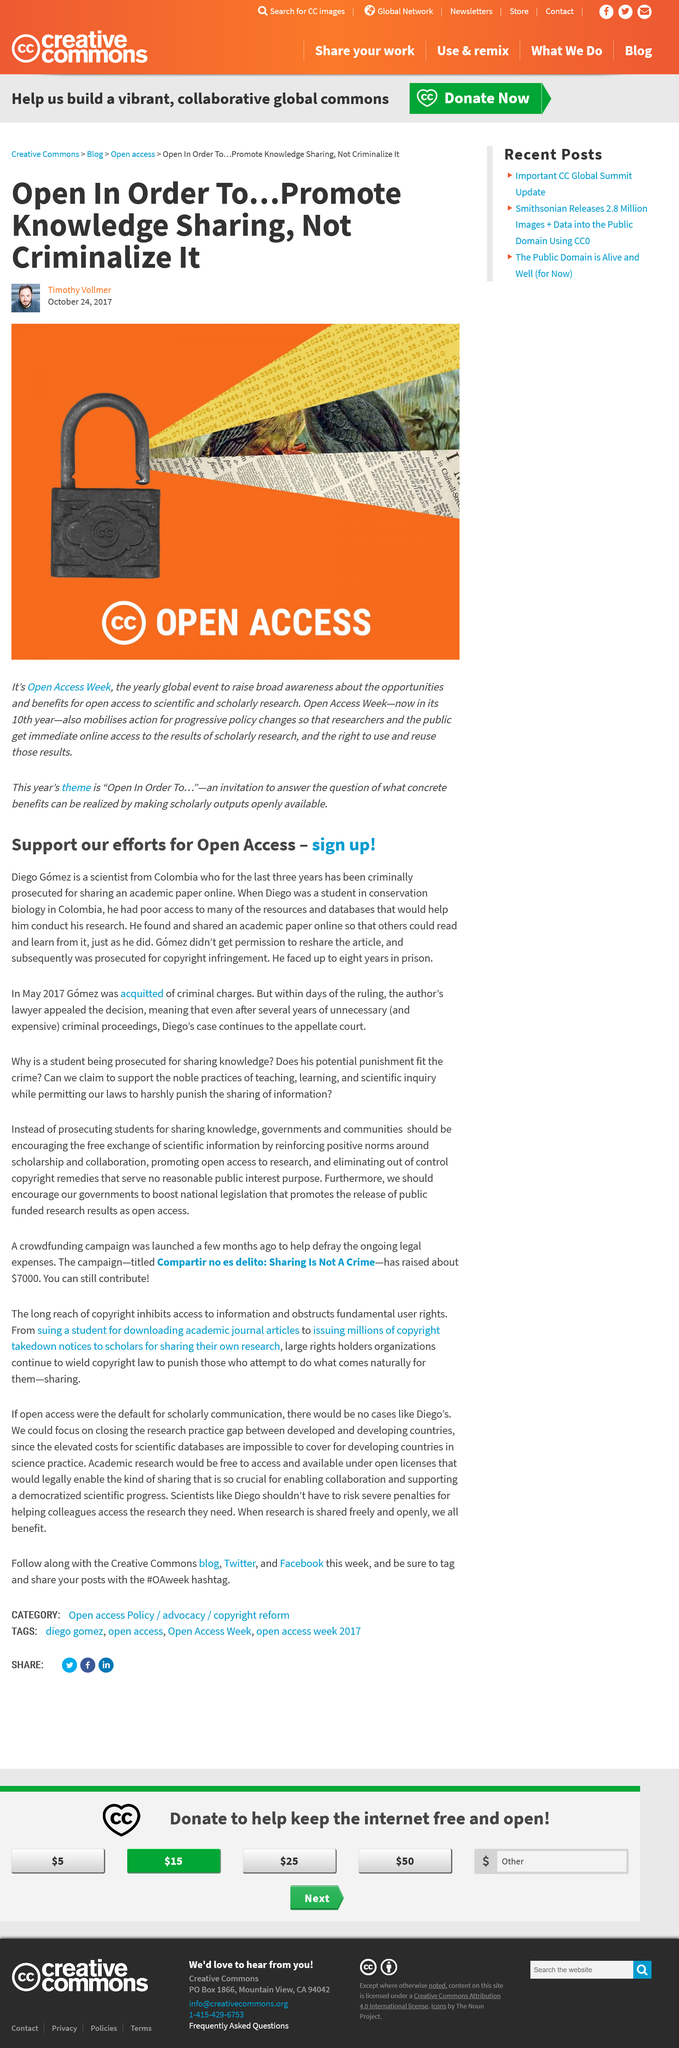Point out several critical features in this image. Diego Gomez was sentenced to up to eight years in prison. Diego was a student in the subject of conservation biology. The case of Diego Gomez is used to garner support for Open Access. Open Access Week has been running for 10 years. The author of this article is Timothy Vollmer. 